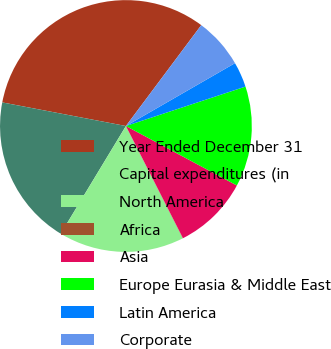Convert chart to OTSL. <chart><loc_0><loc_0><loc_500><loc_500><pie_chart><fcel>Year Ended December 31<fcel>Capital expenditures (in<fcel>North America<fcel>Africa<fcel>Asia<fcel>Europe Eurasia & Middle East<fcel>Latin America<fcel>Corporate<nl><fcel>32.21%<fcel>19.34%<fcel>16.12%<fcel>0.03%<fcel>9.68%<fcel>12.9%<fcel>3.25%<fcel>6.47%<nl></chart> 